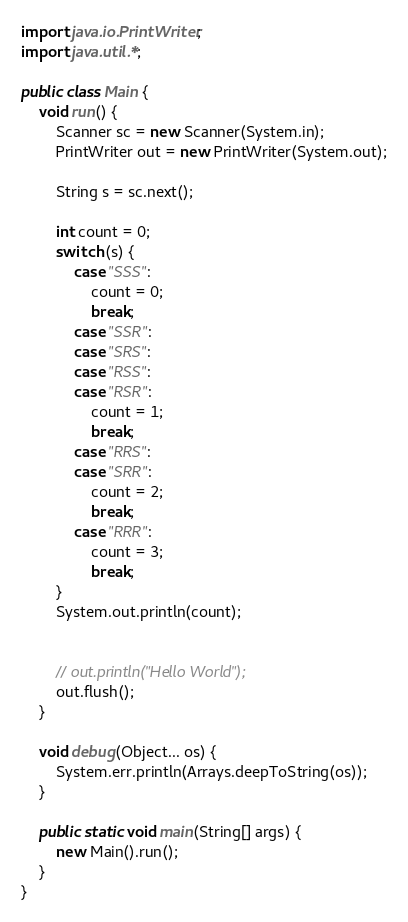<code> <loc_0><loc_0><loc_500><loc_500><_Java_>
import java.io.PrintWriter;
import java.util.*;

public class Main {
    void run() {
        Scanner sc = new Scanner(System.in);
        PrintWriter out = new PrintWriter(System.out);

        String s = sc.next();

        int count = 0;
        switch (s) {
            case "SSS":
                count = 0;
                break;
            case "SSR":
            case "SRS":
            case "RSS":
            case "RSR":
                count = 1;
                break;
            case "RRS":
            case "SRR":
                count = 2;
                break;
            case "RRR":
                count = 3;
                break;
        }
        System.out.println(count);


        // out.println("Hello World");
        out.flush();
    }

    void debug(Object... os) {
        System.err.println(Arrays.deepToString(os));
    }

    public static void main(String[] args) {
        new Main().run();
    }
}
</code> 